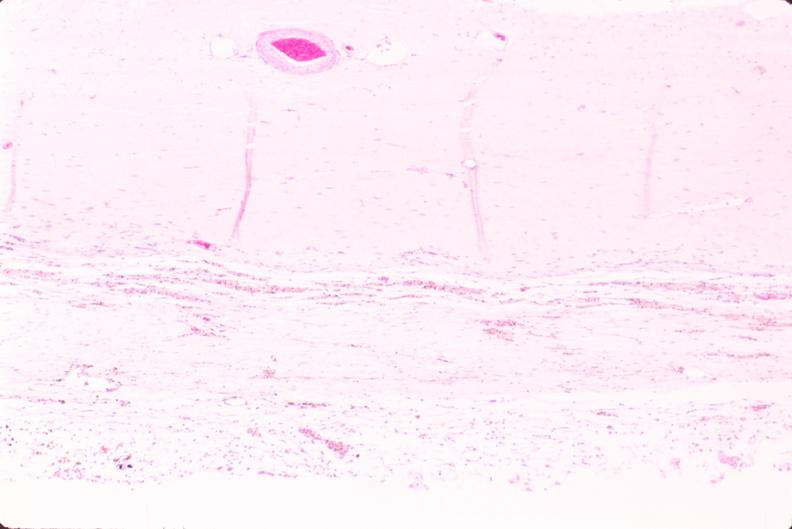what does this image show?
Answer the question using a single word or phrase. Brain 